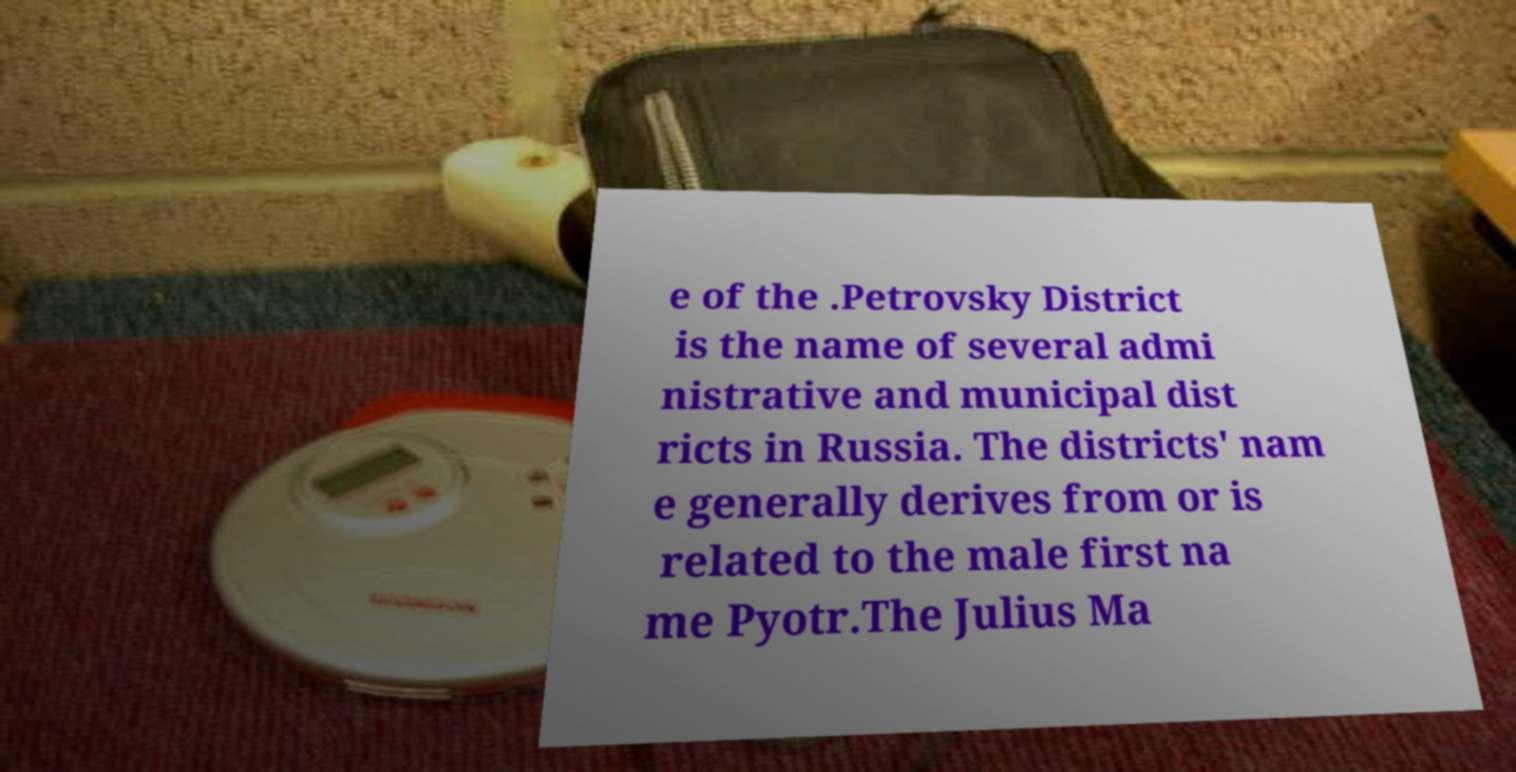Could you assist in decoding the text presented in this image and type it out clearly? e of the .Petrovsky District is the name of several admi nistrative and municipal dist ricts in Russia. The districts' nam e generally derives from or is related to the male first na me Pyotr.The Julius Ma 